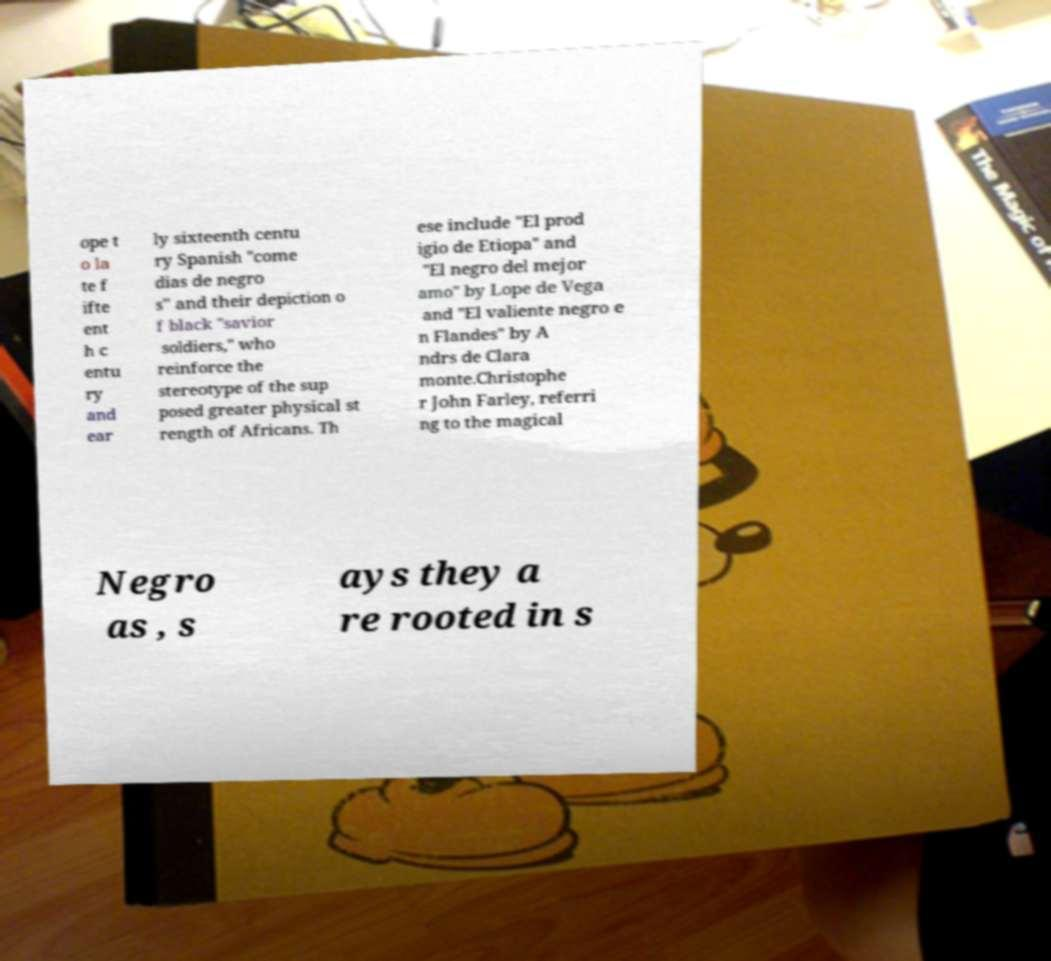Could you extract and type out the text from this image? ope t o la te f ifte ent h c entu ry and ear ly sixteenth centu ry Spanish "come dias de negro s" and their depiction o f black "savior soldiers," who reinforce the stereotype of the sup posed greater physical st rength of Africans. Th ese include "El prod igio de Etiopa" and "El negro del mejor amo" by Lope de Vega and "El valiente negro e n Flandes" by A ndrs de Clara monte.Christophe r John Farley, referri ng to the magical Negro as , s ays they a re rooted in s 